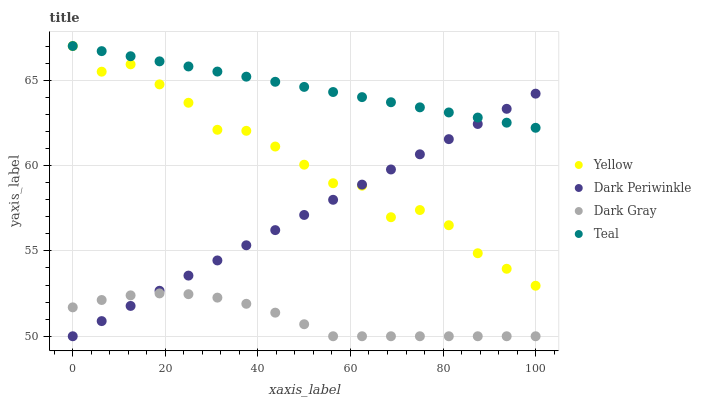Does Dark Gray have the minimum area under the curve?
Answer yes or no. Yes. Does Teal have the maximum area under the curve?
Answer yes or no. Yes. Does Dark Periwinkle have the minimum area under the curve?
Answer yes or no. No. Does Dark Periwinkle have the maximum area under the curve?
Answer yes or no. No. Is Dark Periwinkle the smoothest?
Answer yes or no. Yes. Is Yellow the roughest?
Answer yes or no. Yes. Is Teal the smoothest?
Answer yes or no. No. Is Teal the roughest?
Answer yes or no. No. Does Dark Gray have the lowest value?
Answer yes or no. Yes. Does Teal have the lowest value?
Answer yes or no. No. Does Yellow have the highest value?
Answer yes or no. Yes. Does Dark Periwinkle have the highest value?
Answer yes or no. No. Is Dark Gray less than Teal?
Answer yes or no. Yes. Is Yellow greater than Dark Gray?
Answer yes or no. Yes. Does Dark Periwinkle intersect Dark Gray?
Answer yes or no. Yes. Is Dark Periwinkle less than Dark Gray?
Answer yes or no. No. Is Dark Periwinkle greater than Dark Gray?
Answer yes or no. No. Does Dark Gray intersect Teal?
Answer yes or no. No. 